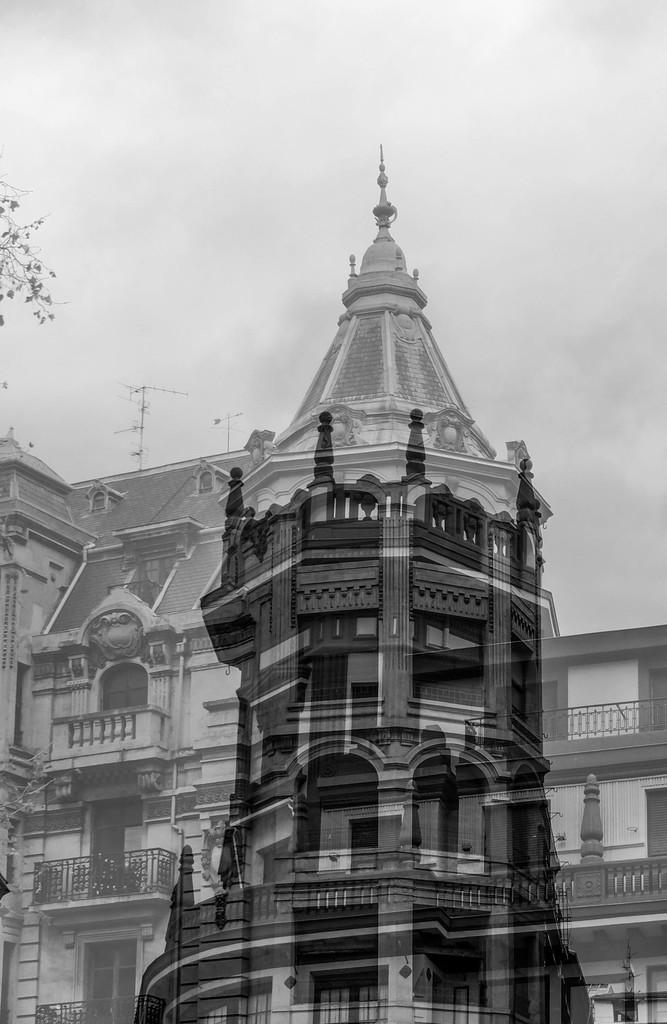Can you describe this image briefly? I see this image is of black and white in color and I see a building and I see the leaves over here. In the background I see the sky. 